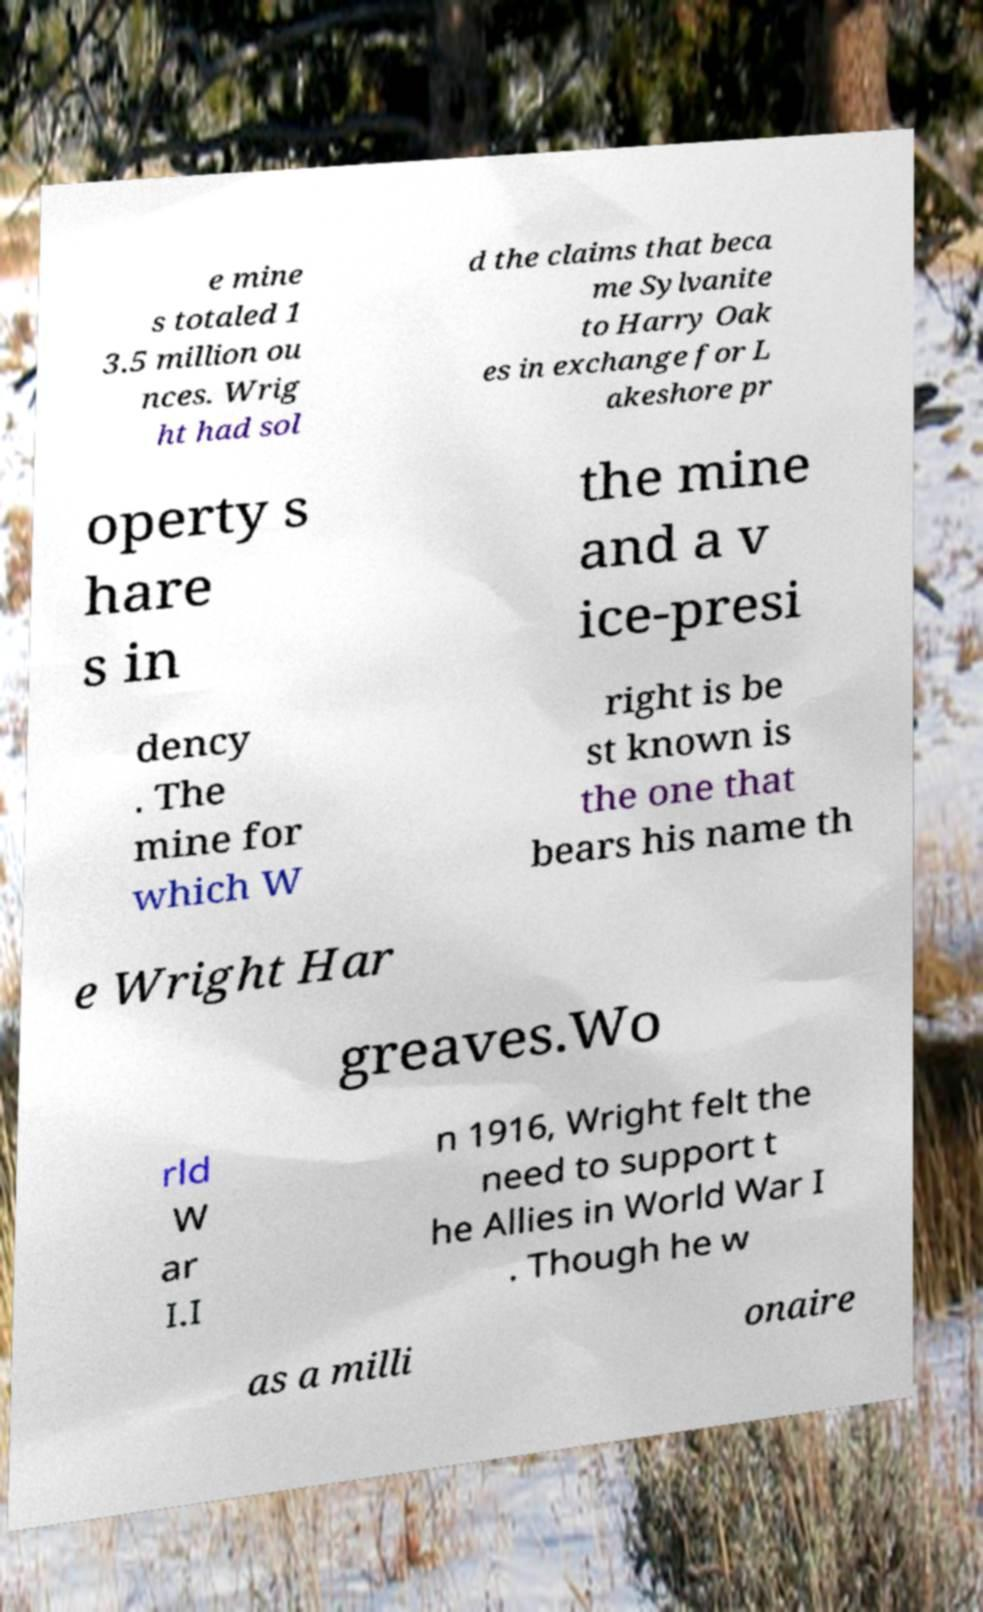Please identify and transcribe the text found in this image. e mine s totaled 1 3.5 million ou nces. Wrig ht had sol d the claims that beca me Sylvanite to Harry Oak es in exchange for L akeshore pr operty s hare s in the mine and a v ice-presi dency . The mine for which W right is be st known is the one that bears his name th e Wright Har greaves.Wo rld W ar I.I n 1916, Wright felt the need to support t he Allies in World War I . Though he w as a milli onaire 